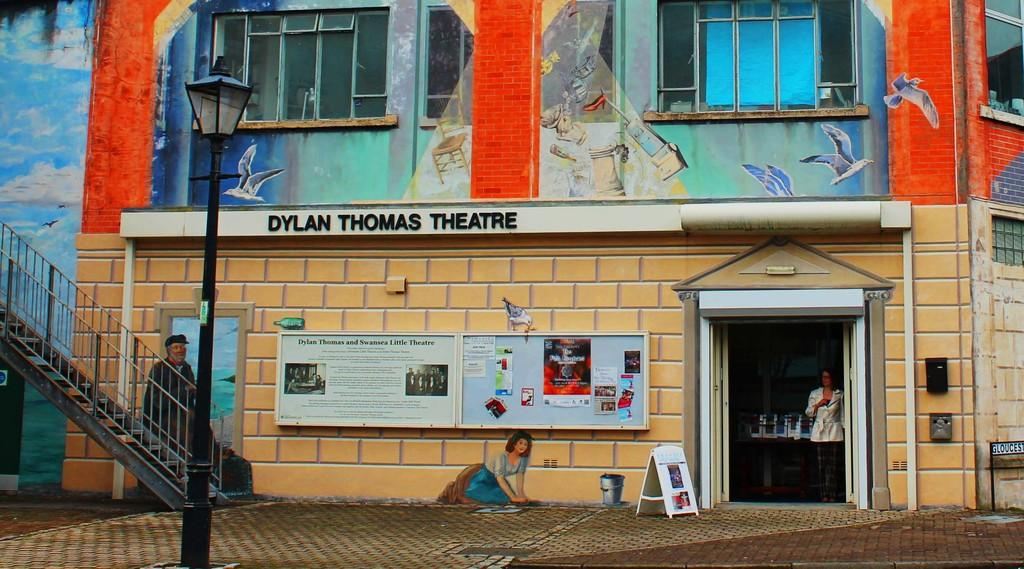What is the main subject of the image? There is a person in the image. What type of structure is visible in the image? There is a building in the image. Can you describe any architectural features in the image? There is a staircase and a pole in the image. What is the source of illumination in the image? There is a light in the image. What materials are present in the image? There are boards in the image. What type of openings can be seen in the building? There are windows in the image. Is there any artwork visible in the image? Yes, there is a painting on a wall in the image. What type of root can be seen growing from the person's head in the image? There is no root growing from the person's head in the image. What reason does the person have for being in the image? The image does not provide any information about the person's reason for being there. 